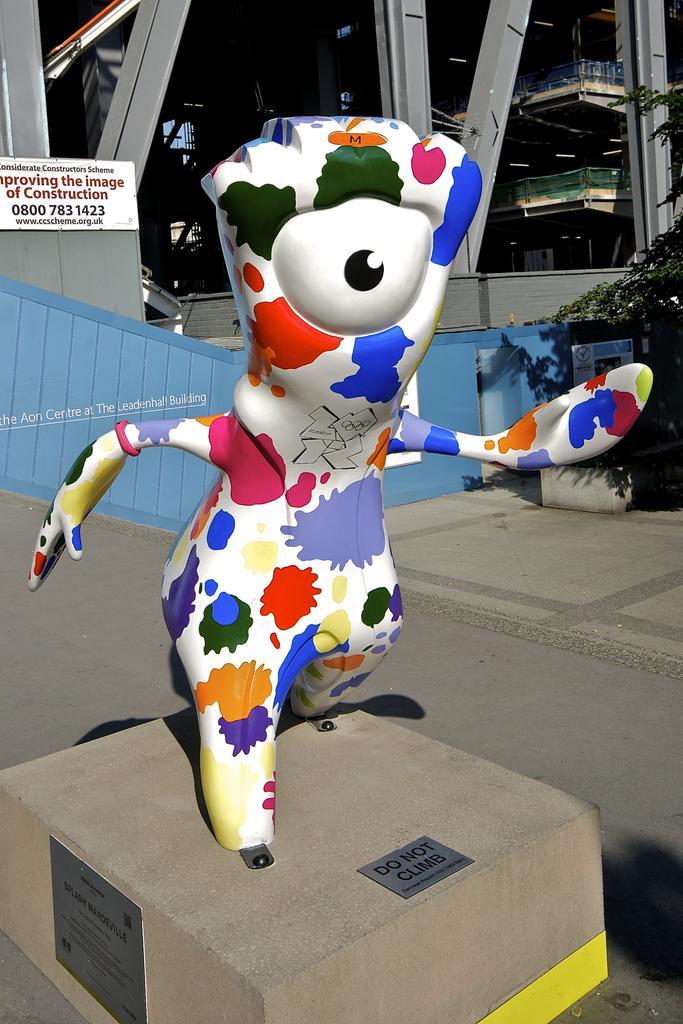How would you summarize this image in a sentence or two? In this picture there is a statue which is in different colors and there is do not climb written on it and there are few iron rods behind it which has something written in the left top corner and there is a tree in the right corner. 